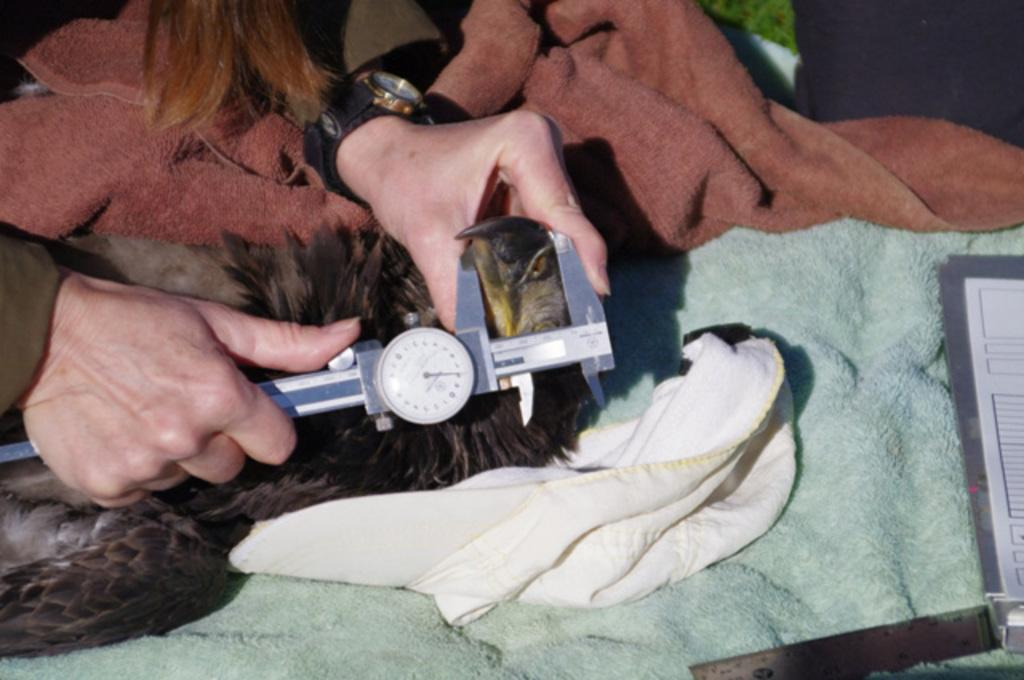Who is present in the image? There is a man in the image. What is the man holding in the image? The man is holding a vernier caliper. What type of fabric can be seen in the image? There is a blanket and a white color cloth in the image. Can you see an airplane nesting on the grain in the image? No, there is no airplane or grain present in the image. 